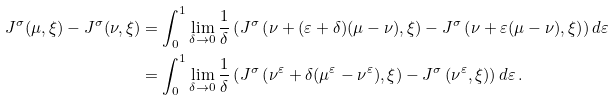<formula> <loc_0><loc_0><loc_500><loc_500>J ^ { \sigma } ( \mu , \xi ) - J ^ { \sigma } ( \nu , \xi ) & = \int _ { 0 } ^ { 1 } \lim _ { \delta \to 0 } \frac { 1 } { \delta } \left ( J ^ { \sigma } \left ( \nu + ( \varepsilon + \delta ) ( \mu - \nu ) , \xi \right ) - J ^ { \sigma } \left ( \nu + \varepsilon ( \mu - \nu ) , \xi \right ) \right ) d \varepsilon \\ & = \int _ { 0 } ^ { 1 } \lim _ { \delta \to 0 } \frac { 1 } { \delta } \left ( J ^ { \sigma } \left ( \nu ^ { \varepsilon } + \delta ( \mu ^ { \varepsilon } - \nu ^ { \varepsilon } ) , \xi \right ) - J ^ { \sigma } \left ( \nu ^ { \varepsilon } , \xi \right ) \right ) d \varepsilon \, .</formula> 